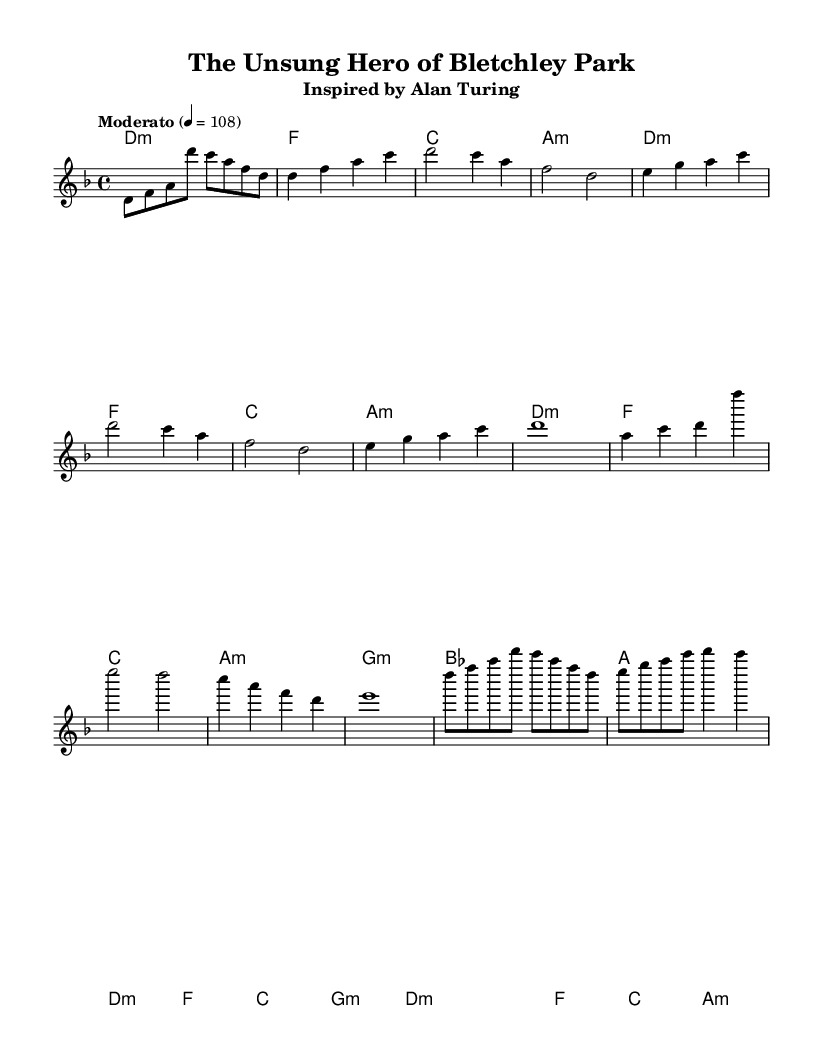What is the key signature of this music? The key signature is indicated in the global settings and shows two flats, which corresponds to the key of D minor.
Answer: D minor What is the time signature of this music? The time signature is found in the global configuration where it is stated as 4 over 4, meaning there are four beats per measure.
Answer: 4/4 What is the tempo marking for this piece? The tempo marking is stated in the global section as "Moderato" with a metronome marking of 108 beats per minute.
Answer: Moderato 108 What is the first chord in the intro? The first chord is displayed in the harmonies section, where the chord is written as d minor.
Answer: D minor How many measures are in the chorus section? By counting the number of measures in the chorus as indicated by the harmony and melody sections, there are four measures in total.
Answer: Four measures Which historical figure inspires this song? The title of the piece indicates that it is inspired by Alan Turing, a key figure in the history of computing and codebreaking during World War II.
Answer: Alan Turing What is the primary musical form used in this piece? Considering the structure of the song with verses, a chorus, and a bridge, it follows a typical rock ballad format, which generally consists of these sections.
Answer: Rock ballad format 